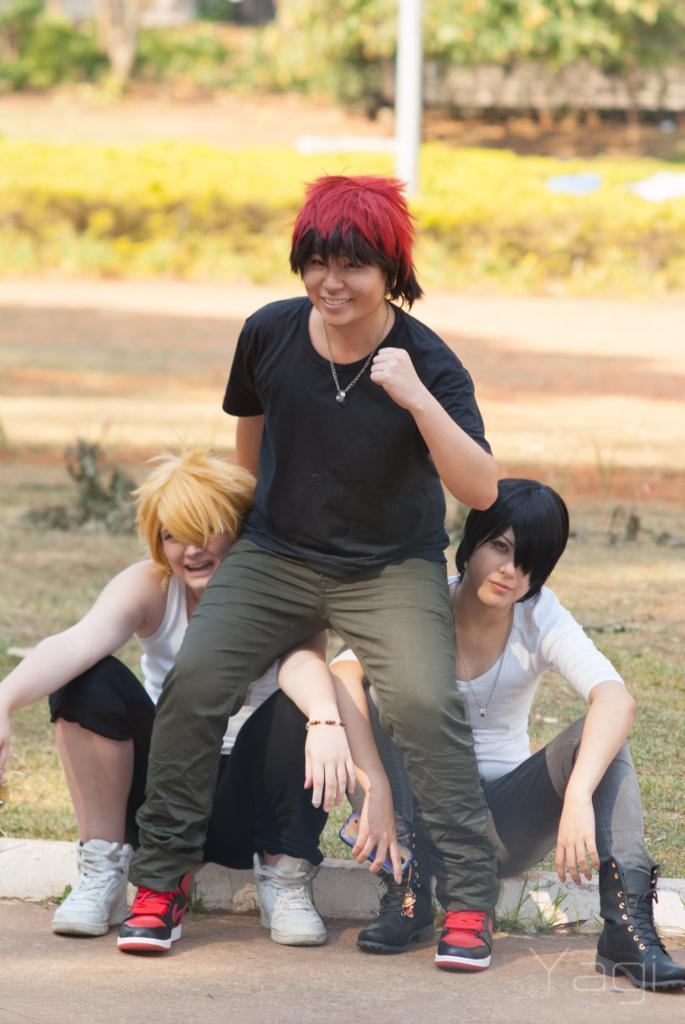How would you summarize this image in a sentence or two? In this image, we can see two women sitting on the ground, there is a woman sitting on the shoulders of the women, in the background there are some plants and trees. 